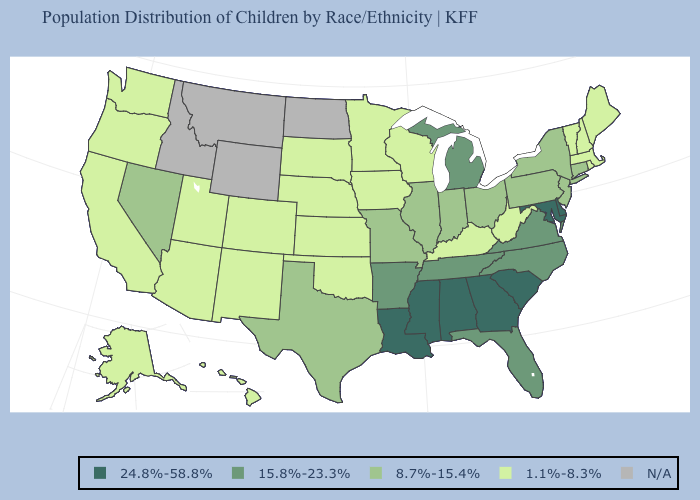Among the states that border Minnesota , which have the lowest value?
Concise answer only. Iowa, South Dakota, Wisconsin. What is the value of Texas?
Write a very short answer. 8.7%-15.4%. Does Nebraska have the lowest value in the MidWest?
Quick response, please. Yes. Does Delaware have the lowest value in the USA?
Concise answer only. No. Which states hav the highest value in the West?
Give a very brief answer. Nevada. Name the states that have a value in the range 1.1%-8.3%?
Give a very brief answer. Alaska, Arizona, California, Colorado, Hawaii, Iowa, Kansas, Kentucky, Maine, Massachusetts, Minnesota, Nebraska, New Hampshire, New Mexico, Oklahoma, Oregon, Rhode Island, South Dakota, Utah, Vermont, Washington, West Virginia, Wisconsin. Which states have the highest value in the USA?
Write a very short answer. Alabama, Delaware, Georgia, Louisiana, Maryland, Mississippi, South Carolina. Name the states that have a value in the range 24.8%-58.8%?
Short answer required. Alabama, Delaware, Georgia, Louisiana, Maryland, Mississippi, South Carolina. What is the lowest value in the USA?
Answer briefly. 1.1%-8.3%. What is the value of Florida?
Give a very brief answer. 15.8%-23.3%. What is the value of South Carolina?
Give a very brief answer. 24.8%-58.8%. What is the value of Missouri?
Quick response, please. 8.7%-15.4%. Which states hav the highest value in the South?
Give a very brief answer. Alabama, Delaware, Georgia, Louisiana, Maryland, Mississippi, South Carolina. 